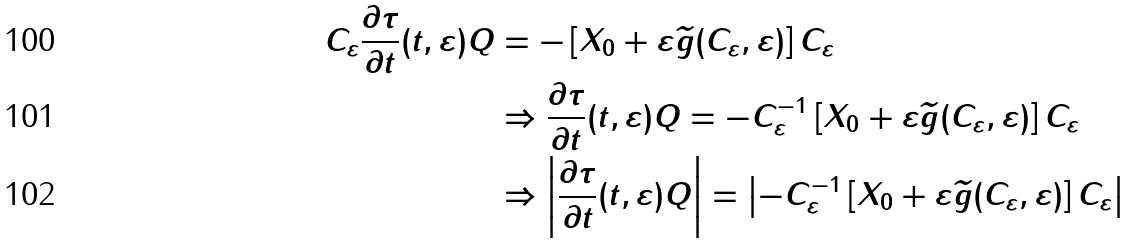Convert formula to latex. <formula><loc_0><loc_0><loc_500><loc_500>C _ { \varepsilon } \frac { \partial { \tau } } { \partial { t } } ( t , \varepsilon ) Q & = - \left [ X _ { 0 } + \varepsilon \widetilde { g } ( C _ { \varepsilon } , \varepsilon ) \right ] C _ { \varepsilon } \\ & \Rightarrow \frac { \partial { \tau } } { \partial { t } } ( t , \varepsilon ) Q = - C _ { \varepsilon } ^ { - 1 } \left [ X _ { 0 } + \varepsilon \widetilde { g } ( C _ { \varepsilon } , \varepsilon ) \right ] C _ { \varepsilon } \\ & \Rightarrow \left | \frac { \partial { \tau } } { \partial { t } } ( t , \varepsilon ) Q \right | = \left | - C _ { \varepsilon } ^ { - 1 } \left [ X _ { 0 } + \varepsilon \widetilde { g } ( C _ { \varepsilon } , \varepsilon ) \right ] C _ { \varepsilon } \right |</formula> 